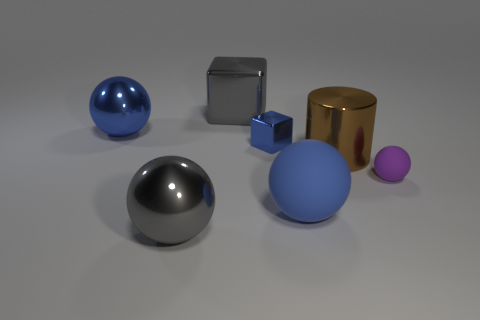Are there any other things that have the same shape as the big brown shiny thing?
Your response must be concise. No. What is the color of the large cylinder that is made of the same material as the big gray cube?
Provide a succinct answer. Brown. Is the blue rubber object the same shape as the small purple object?
Keep it short and to the point. Yes. What number of metallic objects are left of the big matte object and in front of the large gray metal block?
Make the answer very short. 3. How many rubber things are small brown balls or large gray cubes?
Your answer should be compact. 0. There is a sphere on the right side of the matte thing in front of the tiny purple thing; how big is it?
Provide a succinct answer. Small. What is the material of the big sphere that is the same color as the big metal cube?
Provide a succinct answer. Metal. Is there a metal block that is to the left of the large shiny object that is behind the big blue object left of the big gray shiny ball?
Ensure brevity in your answer.  No. Is the ball right of the blue rubber sphere made of the same material as the blue sphere that is in front of the large cylinder?
Give a very brief answer. Yes. How many things are tiny blue matte cylinders or matte spheres to the right of the big blue matte ball?
Your response must be concise. 1. 